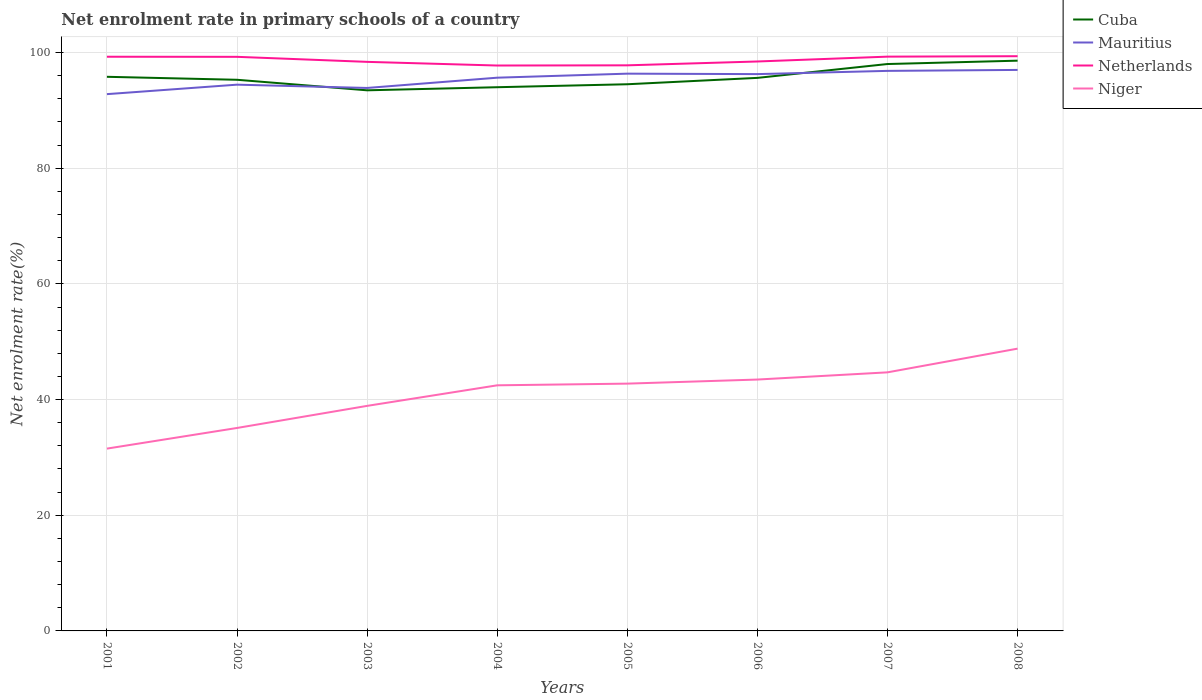How many different coloured lines are there?
Offer a terse response. 4. Does the line corresponding to Mauritius intersect with the line corresponding to Netherlands?
Offer a terse response. No. Across all years, what is the maximum net enrolment rate in primary schools in Niger?
Keep it short and to the point. 31.52. In which year was the net enrolment rate in primary schools in Netherlands maximum?
Offer a terse response. 2004. What is the total net enrolment rate in primary schools in Cuba in the graph?
Keep it short and to the point. -0.33. What is the difference between the highest and the second highest net enrolment rate in primary schools in Netherlands?
Your answer should be very brief. 1.61. What is the difference between the highest and the lowest net enrolment rate in primary schools in Niger?
Provide a succinct answer. 5. How many lines are there?
Ensure brevity in your answer.  4. How many years are there in the graph?
Provide a short and direct response. 8. What is the difference between two consecutive major ticks on the Y-axis?
Provide a short and direct response. 20. Are the values on the major ticks of Y-axis written in scientific E-notation?
Provide a short and direct response. No. How many legend labels are there?
Keep it short and to the point. 4. How are the legend labels stacked?
Offer a terse response. Vertical. What is the title of the graph?
Your response must be concise. Net enrolment rate in primary schools of a country. Does "Kuwait" appear as one of the legend labels in the graph?
Provide a succinct answer. No. What is the label or title of the Y-axis?
Give a very brief answer. Net enrolment rate(%). What is the Net enrolment rate(%) in Cuba in 2001?
Offer a terse response. 95.81. What is the Net enrolment rate(%) of Mauritius in 2001?
Offer a very short reply. 92.81. What is the Net enrolment rate(%) in Netherlands in 2001?
Your answer should be compact. 99.28. What is the Net enrolment rate(%) in Niger in 2001?
Keep it short and to the point. 31.52. What is the Net enrolment rate(%) in Cuba in 2002?
Make the answer very short. 95.29. What is the Net enrolment rate(%) of Mauritius in 2002?
Provide a short and direct response. 94.45. What is the Net enrolment rate(%) in Netherlands in 2002?
Offer a terse response. 99.26. What is the Net enrolment rate(%) of Niger in 2002?
Provide a short and direct response. 35.09. What is the Net enrolment rate(%) of Cuba in 2003?
Offer a terse response. 93.47. What is the Net enrolment rate(%) in Mauritius in 2003?
Your answer should be compact. 93.88. What is the Net enrolment rate(%) in Netherlands in 2003?
Your answer should be very brief. 98.39. What is the Net enrolment rate(%) of Niger in 2003?
Your answer should be compact. 38.91. What is the Net enrolment rate(%) of Cuba in 2004?
Your response must be concise. 94.01. What is the Net enrolment rate(%) of Mauritius in 2004?
Offer a very short reply. 95.65. What is the Net enrolment rate(%) of Netherlands in 2004?
Your answer should be compact. 97.76. What is the Net enrolment rate(%) in Niger in 2004?
Provide a succinct answer. 42.46. What is the Net enrolment rate(%) in Cuba in 2005?
Provide a succinct answer. 94.52. What is the Net enrolment rate(%) in Mauritius in 2005?
Provide a succinct answer. 96.35. What is the Net enrolment rate(%) in Netherlands in 2005?
Your response must be concise. 97.79. What is the Net enrolment rate(%) of Niger in 2005?
Make the answer very short. 42.76. What is the Net enrolment rate(%) in Cuba in 2006?
Give a very brief answer. 95.62. What is the Net enrolment rate(%) of Mauritius in 2006?
Offer a very short reply. 96.27. What is the Net enrolment rate(%) of Netherlands in 2006?
Make the answer very short. 98.46. What is the Net enrolment rate(%) of Niger in 2006?
Keep it short and to the point. 43.46. What is the Net enrolment rate(%) of Cuba in 2007?
Your answer should be compact. 98.02. What is the Net enrolment rate(%) of Mauritius in 2007?
Your answer should be very brief. 96.83. What is the Net enrolment rate(%) of Netherlands in 2007?
Offer a very short reply. 99.29. What is the Net enrolment rate(%) in Niger in 2007?
Give a very brief answer. 44.71. What is the Net enrolment rate(%) in Cuba in 2008?
Offer a very short reply. 98.6. What is the Net enrolment rate(%) of Mauritius in 2008?
Make the answer very short. 97. What is the Net enrolment rate(%) of Netherlands in 2008?
Provide a succinct answer. 99.37. What is the Net enrolment rate(%) in Niger in 2008?
Offer a very short reply. 48.81. Across all years, what is the maximum Net enrolment rate(%) in Cuba?
Make the answer very short. 98.6. Across all years, what is the maximum Net enrolment rate(%) in Mauritius?
Your answer should be compact. 97. Across all years, what is the maximum Net enrolment rate(%) in Netherlands?
Ensure brevity in your answer.  99.37. Across all years, what is the maximum Net enrolment rate(%) in Niger?
Provide a short and direct response. 48.81. Across all years, what is the minimum Net enrolment rate(%) in Cuba?
Provide a succinct answer. 93.47. Across all years, what is the minimum Net enrolment rate(%) in Mauritius?
Keep it short and to the point. 92.81. Across all years, what is the minimum Net enrolment rate(%) in Netherlands?
Provide a succinct answer. 97.76. Across all years, what is the minimum Net enrolment rate(%) in Niger?
Offer a very short reply. 31.52. What is the total Net enrolment rate(%) in Cuba in the graph?
Ensure brevity in your answer.  765.33. What is the total Net enrolment rate(%) of Mauritius in the graph?
Ensure brevity in your answer.  763.24. What is the total Net enrolment rate(%) in Netherlands in the graph?
Provide a succinct answer. 789.59. What is the total Net enrolment rate(%) of Niger in the graph?
Offer a terse response. 327.72. What is the difference between the Net enrolment rate(%) of Cuba in 2001 and that in 2002?
Offer a terse response. 0.52. What is the difference between the Net enrolment rate(%) of Mauritius in 2001 and that in 2002?
Offer a terse response. -1.64. What is the difference between the Net enrolment rate(%) of Netherlands in 2001 and that in 2002?
Make the answer very short. 0.01. What is the difference between the Net enrolment rate(%) in Niger in 2001 and that in 2002?
Offer a terse response. -3.57. What is the difference between the Net enrolment rate(%) in Cuba in 2001 and that in 2003?
Provide a short and direct response. 2.34. What is the difference between the Net enrolment rate(%) of Mauritius in 2001 and that in 2003?
Make the answer very short. -1.07. What is the difference between the Net enrolment rate(%) in Netherlands in 2001 and that in 2003?
Make the answer very short. 0.88. What is the difference between the Net enrolment rate(%) of Niger in 2001 and that in 2003?
Your answer should be very brief. -7.39. What is the difference between the Net enrolment rate(%) of Cuba in 2001 and that in 2004?
Your response must be concise. 1.8. What is the difference between the Net enrolment rate(%) of Mauritius in 2001 and that in 2004?
Offer a terse response. -2.85. What is the difference between the Net enrolment rate(%) in Netherlands in 2001 and that in 2004?
Your answer should be very brief. 1.52. What is the difference between the Net enrolment rate(%) of Niger in 2001 and that in 2004?
Provide a succinct answer. -10.94. What is the difference between the Net enrolment rate(%) in Cuba in 2001 and that in 2005?
Your response must be concise. 1.29. What is the difference between the Net enrolment rate(%) in Mauritius in 2001 and that in 2005?
Provide a short and direct response. -3.54. What is the difference between the Net enrolment rate(%) in Netherlands in 2001 and that in 2005?
Your response must be concise. 1.49. What is the difference between the Net enrolment rate(%) of Niger in 2001 and that in 2005?
Your answer should be compact. -11.23. What is the difference between the Net enrolment rate(%) in Cuba in 2001 and that in 2006?
Make the answer very short. 0.19. What is the difference between the Net enrolment rate(%) in Mauritius in 2001 and that in 2006?
Your answer should be compact. -3.46. What is the difference between the Net enrolment rate(%) in Netherlands in 2001 and that in 2006?
Make the answer very short. 0.82. What is the difference between the Net enrolment rate(%) of Niger in 2001 and that in 2006?
Keep it short and to the point. -11.94. What is the difference between the Net enrolment rate(%) in Cuba in 2001 and that in 2007?
Offer a terse response. -2.21. What is the difference between the Net enrolment rate(%) in Mauritius in 2001 and that in 2007?
Keep it short and to the point. -4.02. What is the difference between the Net enrolment rate(%) of Netherlands in 2001 and that in 2007?
Keep it short and to the point. -0.02. What is the difference between the Net enrolment rate(%) in Niger in 2001 and that in 2007?
Your answer should be compact. -13.19. What is the difference between the Net enrolment rate(%) in Cuba in 2001 and that in 2008?
Your answer should be compact. -2.79. What is the difference between the Net enrolment rate(%) of Mauritius in 2001 and that in 2008?
Make the answer very short. -4.19. What is the difference between the Net enrolment rate(%) in Netherlands in 2001 and that in 2008?
Ensure brevity in your answer.  -0.09. What is the difference between the Net enrolment rate(%) in Niger in 2001 and that in 2008?
Give a very brief answer. -17.29. What is the difference between the Net enrolment rate(%) in Cuba in 2002 and that in 2003?
Your response must be concise. 1.82. What is the difference between the Net enrolment rate(%) of Mauritius in 2002 and that in 2003?
Provide a short and direct response. 0.57. What is the difference between the Net enrolment rate(%) in Netherlands in 2002 and that in 2003?
Keep it short and to the point. 0.87. What is the difference between the Net enrolment rate(%) in Niger in 2002 and that in 2003?
Your answer should be very brief. -3.82. What is the difference between the Net enrolment rate(%) in Cuba in 2002 and that in 2004?
Your answer should be compact. 1.29. What is the difference between the Net enrolment rate(%) in Mauritius in 2002 and that in 2004?
Your response must be concise. -1.21. What is the difference between the Net enrolment rate(%) of Netherlands in 2002 and that in 2004?
Keep it short and to the point. 1.5. What is the difference between the Net enrolment rate(%) in Niger in 2002 and that in 2004?
Offer a terse response. -7.37. What is the difference between the Net enrolment rate(%) of Cuba in 2002 and that in 2005?
Give a very brief answer. 0.77. What is the difference between the Net enrolment rate(%) in Mauritius in 2002 and that in 2005?
Make the answer very short. -1.9. What is the difference between the Net enrolment rate(%) in Netherlands in 2002 and that in 2005?
Give a very brief answer. 1.47. What is the difference between the Net enrolment rate(%) in Niger in 2002 and that in 2005?
Keep it short and to the point. -7.67. What is the difference between the Net enrolment rate(%) of Cuba in 2002 and that in 2006?
Your answer should be very brief. -0.33. What is the difference between the Net enrolment rate(%) of Mauritius in 2002 and that in 2006?
Keep it short and to the point. -1.82. What is the difference between the Net enrolment rate(%) in Netherlands in 2002 and that in 2006?
Provide a succinct answer. 0.81. What is the difference between the Net enrolment rate(%) of Niger in 2002 and that in 2006?
Provide a succinct answer. -8.37. What is the difference between the Net enrolment rate(%) of Cuba in 2002 and that in 2007?
Provide a short and direct response. -2.72. What is the difference between the Net enrolment rate(%) in Mauritius in 2002 and that in 2007?
Make the answer very short. -2.39. What is the difference between the Net enrolment rate(%) in Netherlands in 2002 and that in 2007?
Give a very brief answer. -0.03. What is the difference between the Net enrolment rate(%) in Niger in 2002 and that in 2007?
Your answer should be very brief. -9.62. What is the difference between the Net enrolment rate(%) in Cuba in 2002 and that in 2008?
Your response must be concise. -3.3. What is the difference between the Net enrolment rate(%) of Mauritius in 2002 and that in 2008?
Give a very brief answer. -2.55. What is the difference between the Net enrolment rate(%) in Netherlands in 2002 and that in 2008?
Ensure brevity in your answer.  -0.11. What is the difference between the Net enrolment rate(%) of Niger in 2002 and that in 2008?
Offer a terse response. -13.72. What is the difference between the Net enrolment rate(%) of Cuba in 2003 and that in 2004?
Provide a short and direct response. -0.53. What is the difference between the Net enrolment rate(%) in Mauritius in 2003 and that in 2004?
Make the answer very short. -1.78. What is the difference between the Net enrolment rate(%) in Netherlands in 2003 and that in 2004?
Your response must be concise. 0.63. What is the difference between the Net enrolment rate(%) of Niger in 2003 and that in 2004?
Your response must be concise. -3.55. What is the difference between the Net enrolment rate(%) of Cuba in 2003 and that in 2005?
Provide a succinct answer. -1.05. What is the difference between the Net enrolment rate(%) of Mauritius in 2003 and that in 2005?
Make the answer very short. -2.47. What is the difference between the Net enrolment rate(%) of Netherlands in 2003 and that in 2005?
Keep it short and to the point. 0.6. What is the difference between the Net enrolment rate(%) of Niger in 2003 and that in 2005?
Provide a succinct answer. -3.85. What is the difference between the Net enrolment rate(%) of Cuba in 2003 and that in 2006?
Keep it short and to the point. -2.15. What is the difference between the Net enrolment rate(%) of Mauritius in 2003 and that in 2006?
Provide a succinct answer. -2.39. What is the difference between the Net enrolment rate(%) in Netherlands in 2003 and that in 2006?
Offer a very short reply. -0.06. What is the difference between the Net enrolment rate(%) in Niger in 2003 and that in 2006?
Give a very brief answer. -4.55. What is the difference between the Net enrolment rate(%) in Cuba in 2003 and that in 2007?
Your response must be concise. -4.55. What is the difference between the Net enrolment rate(%) in Mauritius in 2003 and that in 2007?
Your answer should be very brief. -2.95. What is the difference between the Net enrolment rate(%) in Netherlands in 2003 and that in 2007?
Offer a terse response. -0.9. What is the difference between the Net enrolment rate(%) of Niger in 2003 and that in 2007?
Keep it short and to the point. -5.8. What is the difference between the Net enrolment rate(%) in Cuba in 2003 and that in 2008?
Your answer should be compact. -5.12. What is the difference between the Net enrolment rate(%) of Mauritius in 2003 and that in 2008?
Ensure brevity in your answer.  -3.12. What is the difference between the Net enrolment rate(%) of Netherlands in 2003 and that in 2008?
Your response must be concise. -0.98. What is the difference between the Net enrolment rate(%) of Niger in 2003 and that in 2008?
Offer a terse response. -9.9. What is the difference between the Net enrolment rate(%) of Cuba in 2004 and that in 2005?
Your answer should be compact. -0.51. What is the difference between the Net enrolment rate(%) of Mauritius in 2004 and that in 2005?
Keep it short and to the point. -0.7. What is the difference between the Net enrolment rate(%) of Netherlands in 2004 and that in 2005?
Give a very brief answer. -0.03. What is the difference between the Net enrolment rate(%) in Niger in 2004 and that in 2005?
Provide a short and direct response. -0.29. What is the difference between the Net enrolment rate(%) of Cuba in 2004 and that in 2006?
Offer a very short reply. -1.62. What is the difference between the Net enrolment rate(%) in Mauritius in 2004 and that in 2006?
Provide a succinct answer. -0.62. What is the difference between the Net enrolment rate(%) in Netherlands in 2004 and that in 2006?
Keep it short and to the point. -0.7. What is the difference between the Net enrolment rate(%) of Niger in 2004 and that in 2006?
Make the answer very short. -1. What is the difference between the Net enrolment rate(%) in Cuba in 2004 and that in 2007?
Give a very brief answer. -4.01. What is the difference between the Net enrolment rate(%) in Mauritius in 2004 and that in 2007?
Your answer should be very brief. -1.18. What is the difference between the Net enrolment rate(%) of Netherlands in 2004 and that in 2007?
Offer a very short reply. -1.53. What is the difference between the Net enrolment rate(%) in Niger in 2004 and that in 2007?
Provide a succinct answer. -2.24. What is the difference between the Net enrolment rate(%) of Cuba in 2004 and that in 2008?
Your response must be concise. -4.59. What is the difference between the Net enrolment rate(%) in Mauritius in 2004 and that in 2008?
Keep it short and to the point. -1.34. What is the difference between the Net enrolment rate(%) in Netherlands in 2004 and that in 2008?
Keep it short and to the point. -1.61. What is the difference between the Net enrolment rate(%) in Niger in 2004 and that in 2008?
Provide a succinct answer. -6.34. What is the difference between the Net enrolment rate(%) in Cuba in 2005 and that in 2006?
Your answer should be very brief. -1.1. What is the difference between the Net enrolment rate(%) in Mauritius in 2005 and that in 2006?
Make the answer very short. 0.08. What is the difference between the Net enrolment rate(%) of Netherlands in 2005 and that in 2006?
Offer a terse response. -0.67. What is the difference between the Net enrolment rate(%) of Niger in 2005 and that in 2006?
Keep it short and to the point. -0.7. What is the difference between the Net enrolment rate(%) in Cuba in 2005 and that in 2007?
Your response must be concise. -3.5. What is the difference between the Net enrolment rate(%) of Mauritius in 2005 and that in 2007?
Your answer should be compact. -0.48. What is the difference between the Net enrolment rate(%) in Netherlands in 2005 and that in 2007?
Provide a short and direct response. -1.5. What is the difference between the Net enrolment rate(%) of Niger in 2005 and that in 2007?
Your answer should be very brief. -1.95. What is the difference between the Net enrolment rate(%) of Cuba in 2005 and that in 2008?
Your response must be concise. -4.08. What is the difference between the Net enrolment rate(%) of Mauritius in 2005 and that in 2008?
Offer a terse response. -0.65. What is the difference between the Net enrolment rate(%) in Netherlands in 2005 and that in 2008?
Keep it short and to the point. -1.58. What is the difference between the Net enrolment rate(%) in Niger in 2005 and that in 2008?
Your answer should be compact. -6.05. What is the difference between the Net enrolment rate(%) of Cuba in 2006 and that in 2007?
Your answer should be compact. -2.4. What is the difference between the Net enrolment rate(%) of Mauritius in 2006 and that in 2007?
Offer a very short reply. -0.56. What is the difference between the Net enrolment rate(%) in Netherlands in 2006 and that in 2007?
Keep it short and to the point. -0.84. What is the difference between the Net enrolment rate(%) of Niger in 2006 and that in 2007?
Keep it short and to the point. -1.25. What is the difference between the Net enrolment rate(%) in Cuba in 2006 and that in 2008?
Provide a succinct answer. -2.97. What is the difference between the Net enrolment rate(%) in Mauritius in 2006 and that in 2008?
Your response must be concise. -0.73. What is the difference between the Net enrolment rate(%) in Netherlands in 2006 and that in 2008?
Offer a very short reply. -0.91. What is the difference between the Net enrolment rate(%) in Niger in 2006 and that in 2008?
Your answer should be very brief. -5.35. What is the difference between the Net enrolment rate(%) in Cuba in 2007 and that in 2008?
Offer a terse response. -0.58. What is the difference between the Net enrolment rate(%) of Mauritius in 2007 and that in 2008?
Provide a succinct answer. -0.16. What is the difference between the Net enrolment rate(%) of Netherlands in 2007 and that in 2008?
Your answer should be compact. -0.08. What is the difference between the Net enrolment rate(%) in Niger in 2007 and that in 2008?
Give a very brief answer. -4.1. What is the difference between the Net enrolment rate(%) in Cuba in 2001 and the Net enrolment rate(%) in Mauritius in 2002?
Provide a short and direct response. 1.36. What is the difference between the Net enrolment rate(%) of Cuba in 2001 and the Net enrolment rate(%) of Netherlands in 2002?
Make the answer very short. -3.45. What is the difference between the Net enrolment rate(%) of Cuba in 2001 and the Net enrolment rate(%) of Niger in 2002?
Your response must be concise. 60.72. What is the difference between the Net enrolment rate(%) in Mauritius in 2001 and the Net enrolment rate(%) in Netherlands in 2002?
Provide a short and direct response. -6.45. What is the difference between the Net enrolment rate(%) of Mauritius in 2001 and the Net enrolment rate(%) of Niger in 2002?
Provide a short and direct response. 57.72. What is the difference between the Net enrolment rate(%) in Netherlands in 2001 and the Net enrolment rate(%) in Niger in 2002?
Make the answer very short. 64.19. What is the difference between the Net enrolment rate(%) in Cuba in 2001 and the Net enrolment rate(%) in Mauritius in 2003?
Ensure brevity in your answer.  1.93. What is the difference between the Net enrolment rate(%) in Cuba in 2001 and the Net enrolment rate(%) in Netherlands in 2003?
Make the answer very short. -2.58. What is the difference between the Net enrolment rate(%) in Cuba in 2001 and the Net enrolment rate(%) in Niger in 2003?
Your response must be concise. 56.9. What is the difference between the Net enrolment rate(%) in Mauritius in 2001 and the Net enrolment rate(%) in Netherlands in 2003?
Offer a terse response. -5.58. What is the difference between the Net enrolment rate(%) of Mauritius in 2001 and the Net enrolment rate(%) of Niger in 2003?
Provide a succinct answer. 53.9. What is the difference between the Net enrolment rate(%) of Netherlands in 2001 and the Net enrolment rate(%) of Niger in 2003?
Give a very brief answer. 60.37. What is the difference between the Net enrolment rate(%) in Cuba in 2001 and the Net enrolment rate(%) in Mauritius in 2004?
Offer a terse response. 0.15. What is the difference between the Net enrolment rate(%) in Cuba in 2001 and the Net enrolment rate(%) in Netherlands in 2004?
Keep it short and to the point. -1.95. What is the difference between the Net enrolment rate(%) of Cuba in 2001 and the Net enrolment rate(%) of Niger in 2004?
Provide a succinct answer. 53.34. What is the difference between the Net enrolment rate(%) in Mauritius in 2001 and the Net enrolment rate(%) in Netherlands in 2004?
Offer a very short reply. -4.95. What is the difference between the Net enrolment rate(%) of Mauritius in 2001 and the Net enrolment rate(%) of Niger in 2004?
Provide a short and direct response. 50.34. What is the difference between the Net enrolment rate(%) in Netherlands in 2001 and the Net enrolment rate(%) in Niger in 2004?
Make the answer very short. 56.81. What is the difference between the Net enrolment rate(%) in Cuba in 2001 and the Net enrolment rate(%) in Mauritius in 2005?
Ensure brevity in your answer.  -0.54. What is the difference between the Net enrolment rate(%) of Cuba in 2001 and the Net enrolment rate(%) of Netherlands in 2005?
Make the answer very short. -1.98. What is the difference between the Net enrolment rate(%) of Cuba in 2001 and the Net enrolment rate(%) of Niger in 2005?
Ensure brevity in your answer.  53.05. What is the difference between the Net enrolment rate(%) of Mauritius in 2001 and the Net enrolment rate(%) of Netherlands in 2005?
Your response must be concise. -4.98. What is the difference between the Net enrolment rate(%) in Mauritius in 2001 and the Net enrolment rate(%) in Niger in 2005?
Provide a short and direct response. 50.05. What is the difference between the Net enrolment rate(%) of Netherlands in 2001 and the Net enrolment rate(%) of Niger in 2005?
Make the answer very short. 56.52. What is the difference between the Net enrolment rate(%) of Cuba in 2001 and the Net enrolment rate(%) of Mauritius in 2006?
Your answer should be compact. -0.46. What is the difference between the Net enrolment rate(%) of Cuba in 2001 and the Net enrolment rate(%) of Netherlands in 2006?
Offer a very short reply. -2.65. What is the difference between the Net enrolment rate(%) of Cuba in 2001 and the Net enrolment rate(%) of Niger in 2006?
Keep it short and to the point. 52.35. What is the difference between the Net enrolment rate(%) in Mauritius in 2001 and the Net enrolment rate(%) in Netherlands in 2006?
Provide a succinct answer. -5.65. What is the difference between the Net enrolment rate(%) of Mauritius in 2001 and the Net enrolment rate(%) of Niger in 2006?
Provide a succinct answer. 49.35. What is the difference between the Net enrolment rate(%) in Netherlands in 2001 and the Net enrolment rate(%) in Niger in 2006?
Keep it short and to the point. 55.81. What is the difference between the Net enrolment rate(%) in Cuba in 2001 and the Net enrolment rate(%) in Mauritius in 2007?
Provide a short and direct response. -1.02. What is the difference between the Net enrolment rate(%) of Cuba in 2001 and the Net enrolment rate(%) of Netherlands in 2007?
Your response must be concise. -3.48. What is the difference between the Net enrolment rate(%) of Cuba in 2001 and the Net enrolment rate(%) of Niger in 2007?
Provide a short and direct response. 51.1. What is the difference between the Net enrolment rate(%) of Mauritius in 2001 and the Net enrolment rate(%) of Netherlands in 2007?
Your answer should be compact. -6.48. What is the difference between the Net enrolment rate(%) in Mauritius in 2001 and the Net enrolment rate(%) in Niger in 2007?
Provide a succinct answer. 48.1. What is the difference between the Net enrolment rate(%) of Netherlands in 2001 and the Net enrolment rate(%) of Niger in 2007?
Your response must be concise. 54.57. What is the difference between the Net enrolment rate(%) in Cuba in 2001 and the Net enrolment rate(%) in Mauritius in 2008?
Provide a succinct answer. -1.19. What is the difference between the Net enrolment rate(%) of Cuba in 2001 and the Net enrolment rate(%) of Netherlands in 2008?
Provide a succinct answer. -3.56. What is the difference between the Net enrolment rate(%) in Cuba in 2001 and the Net enrolment rate(%) in Niger in 2008?
Give a very brief answer. 47. What is the difference between the Net enrolment rate(%) of Mauritius in 2001 and the Net enrolment rate(%) of Netherlands in 2008?
Your answer should be very brief. -6.56. What is the difference between the Net enrolment rate(%) in Mauritius in 2001 and the Net enrolment rate(%) in Niger in 2008?
Your answer should be compact. 44. What is the difference between the Net enrolment rate(%) in Netherlands in 2001 and the Net enrolment rate(%) in Niger in 2008?
Your response must be concise. 50.47. What is the difference between the Net enrolment rate(%) in Cuba in 2002 and the Net enrolment rate(%) in Mauritius in 2003?
Your answer should be compact. 1.41. What is the difference between the Net enrolment rate(%) in Cuba in 2002 and the Net enrolment rate(%) in Netherlands in 2003?
Offer a very short reply. -3.1. What is the difference between the Net enrolment rate(%) in Cuba in 2002 and the Net enrolment rate(%) in Niger in 2003?
Your response must be concise. 56.38. What is the difference between the Net enrolment rate(%) of Mauritius in 2002 and the Net enrolment rate(%) of Netherlands in 2003?
Offer a terse response. -3.94. What is the difference between the Net enrolment rate(%) of Mauritius in 2002 and the Net enrolment rate(%) of Niger in 2003?
Give a very brief answer. 55.54. What is the difference between the Net enrolment rate(%) in Netherlands in 2002 and the Net enrolment rate(%) in Niger in 2003?
Your answer should be very brief. 60.35. What is the difference between the Net enrolment rate(%) of Cuba in 2002 and the Net enrolment rate(%) of Mauritius in 2004?
Provide a succinct answer. -0.36. What is the difference between the Net enrolment rate(%) of Cuba in 2002 and the Net enrolment rate(%) of Netherlands in 2004?
Offer a very short reply. -2.46. What is the difference between the Net enrolment rate(%) of Cuba in 2002 and the Net enrolment rate(%) of Niger in 2004?
Provide a short and direct response. 52.83. What is the difference between the Net enrolment rate(%) in Mauritius in 2002 and the Net enrolment rate(%) in Netherlands in 2004?
Provide a short and direct response. -3.31. What is the difference between the Net enrolment rate(%) of Mauritius in 2002 and the Net enrolment rate(%) of Niger in 2004?
Provide a succinct answer. 51.98. What is the difference between the Net enrolment rate(%) of Netherlands in 2002 and the Net enrolment rate(%) of Niger in 2004?
Your response must be concise. 56.8. What is the difference between the Net enrolment rate(%) in Cuba in 2002 and the Net enrolment rate(%) in Mauritius in 2005?
Ensure brevity in your answer.  -1.06. What is the difference between the Net enrolment rate(%) of Cuba in 2002 and the Net enrolment rate(%) of Netherlands in 2005?
Provide a short and direct response. -2.5. What is the difference between the Net enrolment rate(%) in Cuba in 2002 and the Net enrolment rate(%) in Niger in 2005?
Ensure brevity in your answer.  52.54. What is the difference between the Net enrolment rate(%) of Mauritius in 2002 and the Net enrolment rate(%) of Netherlands in 2005?
Your answer should be compact. -3.34. What is the difference between the Net enrolment rate(%) of Mauritius in 2002 and the Net enrolment rate(%) of Niger in 2005?
Ensure brevity in your answer.  51.69. What is the difference between the Net enrolment rate(%) of Netherlands in 2002 and the Net enrolment rate(%) of Niger in 2005?
Provide a short and direct response. 56.5. What is the difference between the Net enrolment rate(%) of Cuba in 2002 and the Net enrolment rate(%) of Mauritius in 2006?
Provide a succinct answer. -0.98. What is the difference between the Net enrolment rate(%) of Cuba in 2002 and the Net enrolment rate(%) of Netherlands in 2006?
Give a very brief answer. -3.16. What is the difference between the Net enrolment rate(%) of Cuba in 2002 and the Net enrolment rate(%) of Niger in 2006?
Offer a very short reply. 51.83. What is the difference between the Net enrolment rate(%) of Mauritius in 2002 and the Net enrolment rate(%) of Netherlands in 2006?
Keep it short and to the point. -4.01. What is the difference between the Net enrolment rate(%) in Mauritius in 2002 and the Net enrolment rate(%) in Niger in 2006?
Provide a short and direct response. 50.99. What is the difference between the Net enrolment rate(%) in Netherlands in 2002 and the Net enrolment rate(%) in Niger in 2006?
Give a very brief answer. 55.8. What is the difference between the Net enrolment rate(%) in Cuba in 2002 and the Net enrolment rate(%) in Mauritius in 2007?
Your response must be concise. -1.54. What is the difference between the Net enrolment rate(%) of Cuba in 2002 and the Net enrolment rate(%) of Netherlands in 2007?
Offer a terse response. -4. What is the difference between the Net enrolment rate(%) of Cuba in 2002 and the Net enrolment rate(%) of Niger in 2007?
Your response must be concise. 50.58. What is the difference between the Net enrolment rate(%) in Mauritius in 2002 and the Net enrolment rate(%) in Netherlands in 2007?
Offer a terse response. -4.84. What is the difference between the Net enrolment rate(%) of Mauritius in 2002 and the Net enrolment rate(%) of Niger in 2007?
Offer a terse response. 49.74. What is the difference between the Net enrolment rate(%) in Netherlands in 2002 and the Net enrolment rate(%) in Niger in 2007?
Keep it short and to the point. 54.55. What is the difference between the Net enrolment rate(%) of Cuba in 2002 and the Net enrolment rate(%) of Mauritius in 2008?
Offer a very short reply. -1.7. What is the difference between the Net enrolment rate(%) in Cuba in 2002 and the Net enrolment rate(%) in Netherlands in 2008?
Offer a terse response. -4.08. What is the difference between the Net enrolment rate(%) of Cuba in 2002 and the Net enrolment rate(%) of Niger in 2008?
Offer a very short reply. 46.49. What is the difference between the Net enrolment rate(%) of Mauritius in 2002 and the Net enrolment rate(%) of Netherlands in 2008?
Give a very brief answer. -4.92. What is the difference between the Net enrolment rate(%) in Mauritius in 2002 and the Net enrolment rate(%) in Niger in 2008?
Give a very brief answer. 45.64. What is the difference between the Net enrolment rate(%) of Netherlands in 2002 and the Net enrolment rate(%) of Niger in 2008?
Offer a terse response. 50.45. What is the difference between the Net enrolment rate(%) of Cuba in 2003 and the Net enrolment rate(%) of Mauritius in 2004?
Offer a very short reply. -2.18. What is the difference between the Net enrolment rate(%) in Cuba in 2003 and the Net enrolment rate(%) in Netherlands in 2004?
Provide a succinct answer. -4.29. What is the difference between the Net enrolment rate(%) of Cuba in 2003 and the Net enrolment rate(%) of Niger in 2004?
Your answer should be very brief. 51.01. What is the difference between the Net enrolment rate(%) in Mauritius in 2003 and the Net enrolment rate(%) in Netherlands in 2004?
Your answer should be very brief. -3.88. What is the difference between the Net enrolment rate(%) in Mauritius in 2003 and the Net enrolment rate(%) in Niger in 2004?
Provide a short and direct response. 51.41. What is the difference between the Net enrolment rate(%) in Netherlands in 2003 and the Net enrolment rate(%) in Niger in 2004?
Offer a terse response. 55.93. What is the difference between the Net enrolment rate(%) in Cuba in 2003 and the Net enrolment rate(%) in Mauritius in 2005?
Your answer should be compact. -2.88. What is the difference between the Net enrolment rate(%) of Cuba in 2003 and the Net enrolment rate(%) of Netherlands in 2005?
Your answer should be compact. -4.32. What is the difference between the Net enrolment rate(%) in Cuba in 2003 and the Net enrolment rate(%) in Niger in 2005?
Offer a terse response. 50.71. What is the difference between the Net enrolment rate(%) of Mauritius in 2003 and the Net enrolment rate(%) of Netherlands in 2005?
Offer a terse response. -3.91. What is the difference between the Net enrolment rate(%) of Mauritius in 2003 and the Net enrolment rate(%) of Niger in 2005?
Provide a succinct answer. 51.12. What is the difference between the Net enrolment rate(%) of Netherlands in 2003 and the Net enrolment rate(%) of Niger in 2005?
Offer a terse response. 55.63. What is the difference between the Net enrolment rate(%) of Cuba in 2003 and the Net enrolment rate(%) of Mauritius in 2006?
Your answer should be very brief. -2.8. What is the difference between the Net enrolment rate(%) in Cuba in 2003 and the Net enrolment rate(%) in Netherlands in 2006?
Offer a terse response. -4.98. What is the difference between the Net enrolment rate(%) of Cuba in 2003 and the Net enrolment rate(%) of Niger in 2006?
Give a very brief answer. 50.01. What is the difference between the Net enrolment rate(%) of Mauritius in 2003 and the Net enrolment rate(%) of Netherlands in 2006?
Keep it short and to the point. -4.58. What is the difference between the Net enrolment rate(%) of Mauritius in 2003 and the Net enrolment rate(%) of Niger in 2006?
Offer a very short reply. 50.42. What is the difference between the Net enrolment rate(%) in Netherlands in 2003 and the Net enrolment rate(%) in Niger in 2006?
Keep it short and to the point. 54.93. What is the difference between the Net enrolment rate(%) of Cuba in 2003 and the Net enrolment rate(%) of Mauritius in 2007?
Your answer should be compact. -3.36. What is the difference between the Net enrolment rate(%) of Cuba in 2003 and the Net enrolment rate(%) of Netherlands in 2007?
Your response must be concise. -5.82. What is the difference between the Net enrolment rate(%) of Cuba in 2003 and the Net enrolment rate(%) of Niger in 2007?
Your answer should be compact. 48.76. What is the difference between the Net enrolment rate(%) in Mauritius in 2003 and the Net enrolment rate(%) in Netherlands in 2007?
Offer a terse response. -5.41. What is the difference between the Net enrolment rate(%) in Mauritius in 2003 and the Net enrolment rate(%) in Niger in 2007?
Ensure brevity in your answer.  49.17. What is the difference between the Net enrolment rate(%) in Netherlands in 2003 and the Net enrolment rate(%) in Niger in 2007?
Provide a short and direct response. 53.68. What is the difference between the Net enrolment rate(%) in Cuba in 2003 and the Net enrolment rate(%) in Mauritius in 2008?
Offer a very short reply. -3.53. What is the difference between the Net enrolment rate(%) in Cuba in 2003 and the Net enrolment rate(%) in Netherlands in 2008?
Offer a terse response. -5.9. What is the difference between the Net enrolment rate(%) in Cuba in 2003 and the Net enrolment rate(%) in Niger in 2008?
Keep it short and to the point. 44.66. What is the difference between the Net enrolment rate(%) in Mauritius in 2003 and the Net enrolment rate(%) in Netherlands in 2008?
Your answer should be very brief. -5.49. What is the difference between the Net enrolment rate(%) in Mauritius in 2003 and the Net enrolment rate(%) in Niger in 2008?
Give a very brief answer. 45.07. What is the difference between the Net enrolment rate(%) in Netherlands in 2003 and the Net enrolment rate(%) in Niger in 2008?
Your response must be concise. 49.58. What is the difference between the Net enrolment rate(%) of Cuba in 2004 and the Net enrolment rate(%) of Mauritius in 2005?
Offer a terse response. -2.35. What is the difference between the Net enrolment rate(%) in Cuba in 2004 and the Net enrolment rate(%) in Netherlands in 2005?
Offer a very short reply. -3.78. What is the difference between the Net enrolment rate(%) of Cuba in 2004 and the Net enrolment rate(%) of Niger in 2005?
Your answer should be very brief. 51.25. What is the difference between the Net enrolment rate(%) in Mauritius in 2004 and the Net enrolment rate(%) in Netherlands in 2005?
Offer a very short reply. -2.14. What is the difference between the Net enrolment rate(%) in Mauritius in 2004 and the Net enrolment rate(%) in Niger in 2005?
Give a very brief answer. 52.9. What is the difference between the Net enrolment rate(%) of Netherlands in 2004 and the Net enrolment rate(%) of Niger in 2005?
Offer a terse response. 55. What is the difference between the Net enrolment rate(%) of Cuba in 2004 and the Net enrolment rate(%) of Mauritius in 2006?
Make the answer very short. -2.27. What is the difference between the Net enrolment rate(%) in Cuba in 2004 and the Net enrolment rate(%) in Netherlands in 2006?
Your answer should be compact. -4.45. What is the difference between the Net enrolment rate(%) of Cuba in 2004 and the Net enrolment rate(%) of Niger in 2006?
Your response must be concise. 50.54. What is the difference between the Net enrolment rate(%) of Mauritius in 2004 and the Net enrolment rate(%) of Netherlands in 2006?
Your answer should be compact. -2.8. What is the difference between the Net enrolment rate(%) of Mauritius in 2004 and the Net enrolment rate(%) of Niger in 2006?
Offer a terse response. 52.19. What is the difference between the Net enrolment rate(%) of Netherlands in 2004 and the Net enrolment rate(%) of Niger in 2006?
Offer a terse response. 54.3. What is the difference between the Net enrolment rate(%) of Cuba in 2004 and the Net enrolment rate(%) of Mauritius in 2007?
Provide a succinct answer. -2.83. What is the difference between the Net enrolment rate(%) in Cuba in 2004 and the Net enrolment rate(%) in Netherlands in 2007?
Give a very brief answer. -5.29. What is the difference between the Net enrolment rate(%) of Cuba in 2004 and the Net enrolment rate(%) of Niger in 2007?
Your answer should be very brief. 49.3. What is the difference between the Net enrolment rate(%) of Mauritius in 2004 and the Net enrolment rate(%) of Netherlands in 2007?
Provide a short and direct response. -3.64. What is the difference between the Net enrolment rate(%) of Mauritius in 2004 and the Net enrolment rate(%) of Niger in 2007?
Provide a short and direct response. 50.95. What is the difference between the Net enrolment rate(%) of Netherlands in 2004 and the Net enrolment rate(%) of Niger in 2007?
Keep it short and to the point. 53.05. What is the difference between the Net enrolment rate(%) of Cuba in 2004 and the Net enrolment rate(%) of Mauritius in 2008?
Your answer should be very brief. -2.99. What is the difference between the Net enrolment rate(%) of Cuba in 2004 and the Net enrolment rate(%) of Netherlands in 2008?
Your response must be concise. -5.36. What is the difference between the Net enrolment rate(%) in Cuba in 2004 and the Net enrolment rate(%) in Niger in 2008?
Give a very brief answer. 45.2. What is the difference between the Net enrolment rate(%) in Mauritius in 2004 and the Net enrolment rate(%) in Netherlands in 2008?
Provide a succinct answer. -3.72. What is the difference between the Net enrolment rate(%) of Mauritius in 2004 and the Net enrolment rate(%) of Niger in 2008?
Ensure brevity in your answer.  46.85. What is the difference between the Net enrolment rate(%) in Netherlands in 2004 and the Net enrolment rate(%) in Niger in 2008?
Offer a very short reply. 48.95. What is the difference between the Net enrolment rate(%) of Cuba in 2005 and the Net enrolment rate(%) of Mauritius in 2006?
Provide a succinct answer. -1.75. What is the difference between the Net enrolment rate(%) in Cuba in 2005 and the Net enrolment rate(%) in Netherlands in 2006?
Keep it short and to the point. -3.94. What is the difference between the Net enrolment rate(%) of Cuba in 2005 and the Net enrolment rate(%) of Niger in 2006?
Your response must be concise. 51.06. What is the difference between the Net enrolment rate(%) of Mauritius in 2005 and the Net enrolment rate(%) of Netherlands in 2006?
Offer a terse response. -2.1. What is the difference between the Net enrolment rate(%) in Mauritius in 2005 and the Net enrolment rate(%) in Niger in 2006?
Your answer should be very brief. 52.89. What is the difference between the Net enrolment rate(%) in Netherlands in 2005 and the Net enrolment rate(%) in Niger in 2006?
Your answer should be very brief. 54.33. What is the difference between the Net enrolment rate(%) of Cuba in 2005 and the Net enrolment rate(%) of Mauritius in 2007?
Offer a terse response. -2.31. What is the difference between the Net enrolment rate(%) of Cuba in 2005 and the Net enrolment rate(%) of Netherlands in 2007?
Give a very brief answer. -4.77. What is the difference between the Net enrolment rate(%) in Cuba in 2005 and the Net enrolment rate(%) in Niger in 2007?
Make the answer very short. 49.81. What is the difference between the Net enrolment rate(%) of Mauritius in 2005 and the Net enrolment rate(%) of Netherlands in 2007?
Your answer should be compact. -2.94. What is the difference between the Net enrolment rate(%) of Mauritius in 2005 and the Net enrolment rate(%) of Niger in 2007?
Your response must be concise. 51.64. What is the difference between the Net enrolment rate(%) of Netherlands in 2005 and the Net enrolment rate(%) of Niger in 2007?
Keep it short and to the point. 53.08. What is the difference between the Net enrolment rate(%) in Cuba in 2005 and the Net enrolment rate(%) in Mauritius in 2008?
Provide a short and direct response. -2.48. What is the difference between the Net enrolment rate(%) of Cuba in 2005 and the Net enrolment rate(%) of Netherlands in 2008?
Give a very brief answer. -4.85. What is the difference between the Net enrolment rate(%) in Cuba in 2005 and the Net enrolment rate(%) in Niger in 2008?
Your answer should be very brief. 45.71. What is the difference between the Net enrolment rate(%) in Mauritius in 2005 and the Net enrolment rate(%) in Netherlands in 2008?
Provide a short and direct response. -3.02. What is the difference between the Net enrolment rate(%) in Mauritius in 2005 and the Net enrolment rate(%) in Niger in 2008?
Provide a short and direct response. 47.54. What is the difference between the Net enrolment rate(%) of Netherlands in 2005 and the Net enrolment rate(%) of Niger in 2008?
Provide a short and direct response. 48.98. What is the difference between the Net enrolment rate(%) in Cuba in 2006 and the Net enrolment rate(%) in Mauritius in 2007?
Offer a terse response. -1.21. What is the difference between the Net enrolment rate(%) of Cuba in 2006 and the Net enrolment rate(%) of Netherlands in 2007?
Your answer should be very brief. -3.67. What is the difference between the Net enrolment rate(%) of Cuba in 2006 and the Net enrolment rate(%) of Niger in 2007?
Give a very brief answer. 50.91. What is the difference between the Net enrolment rate(%) of Mauritius in 2006 and the Net enrolment rate(%) of Netherlands in 2007?
Your response must be concise. -3.02. What is the difference between the Net enrolment rate(%) in Mauritius in 2006 and the Net enrolment rate(%) in Niger in 2007?
Give a very brief answer. 51.56. What is the difference between the Net enrolment rate(%) of Netherlands in 2006 and the Net enrolment rate(%) of Niger in 2007?
Offer a terse response. 53.75. What is the difference between the Net enrolment rate(%) in Cuba in 2006 and the Net enrolment rate(%) in Mauritius in 2008?
Keep it short and to the point. -1.38. What is the difference between the Net enrolment rate(%) of Cuba in 2006 and the Net enrolment rate(%) of Netherlands in 2008?
Your response must be concise. -3.75. What is the difference between the Net enrolment rate(%) of Cuba in 2006 and the Net enrolment rate(%) of Niger in 2008?
Offer a terse response. 46.81. What is the difference between the Net enrolment rate(%) in Mauritius in 2006 and the Net enrolment rate(%) in Netherlands in 2008?
Offer a terse response. -3.1. What is the difference between the Net enrolment rate(%) in Mauritius in 2006 and the Net enrolment rate(%) in Niger in 2008?
Ensure brevity in your answer.  47.46. What is the difference between the Net enrolment rate(%) of Netherlands in 2006 and the Net enrolment rate(%) of Niger in 2008?
Offer a terse response. 49.65. What is the difference between the Net enrolment rate(%) of Cuba in 2007 and the Net enrolment rate(%) of Mauritius in 2008?
Your answer should be compact. 1.02. What is the difference between the Net enrolment rate(%) of Cuba in 2007 and the Net enrolment rate(%) of Netherlands in 2008?
Your response must be concise. -1.35. What is the difference between the Net enrolment rate(%) of Cuba in 2007 and the Net enrolment rate(%) of Niger in 2008?
Your answer should be very brief. 49.21. What is the difference between the Net enrolment rate(%) in Mauritius in 2007 and the Net enrolment rate(%) in Netherlands in 2008?
Keep it short and to the point. -2.54. What is the difference between the Net enrolment rate(%) in Mauritius in 2007 and the Net enrolment rate(%) in Niger in 2008?
Keep it short and to the point. 48.03. What is the difference between the Net enrolment rate(%) of Netherlands in 2007 and the Net enrolment rate(%) of Niger in 2008?
Give a very brief answer. 50.48. What is the average Net enrolment rate(%) of Cuba per year?
Keep it short and to the point. 95.67. What is the average Net enrolment rate(%) in Mauritius per year?
Your answer should be compact. 95.41. What is the average Net enrolment rate(%) in Netherlands per year?
Provide a short and direct response. 98.7. What is the average Net enrolment rate(%) of Niger per year?
Offer a terse response. 40.97. In the year 2001, what is the difference between the Net enrolment rate(%) in Cuba and Net enrolment rate(%) in Mauritius?
Ensure brevity in your answer.  3. In the year 2001, what is the difference between the Net enrolment rate(%) in Cuba and Net enrolment rate(%) in Netherlands?
Your answer should be very brief. -3.47. In the year 2001, what is the difference between the Net enrolment rate(%) in Cuba and Net enrolment rate(%) in Niger?
Provide a succinct answer. 64.29. In the year 2001, what is the difference between the Net enrolment rate(%) in Mauritius and Net enrolment rate(%) in Netherlands?
Give a very brief answer. -6.47. In the year 2001, what is the difference between the Net enrolment rate(%) of Mauritius and Net enrolment rate(%) of Niger?
Provide a short and direct response. 61.29. In the year 2001, what is the difference between the Net enrolment rate(%) in Netherlands and Net enrolment rate(%) in Niger?
Provide a short and direct response. 67.75. In the year 2002, what is the difference between the Net enrolment rate(%) in Cuba and Net enrolment rate(%) in Mauritius?
Your answer should be very brief. 0.85. In the year 2002, what is the difference between the Net enrolment rate(%) in Cuba and Net enrolment rate(%) in Netherlands?
Provide a short and direct response. -3.97. In the year 2002, what is the difference between the Net enrolment rate(%) in Cuba and Net enrolment rate(%) in Niger?
Give a very brief answer. 60.2. In the year 2002, what is the difference between the Net enrolment rate(%) in Mauritius and Net enrolment rate(%) in Netherlands?
Ensure brevity in your answer.  -4.81. In the year 2002, what is the difference between the Net enrolment rate(%) in Mauritius and Net enrolment rate(%) in Niger?
Provide a short and direct response. 59.36. In the year 2002, what is the difference between the Net enrolment rate(%) of Netherlands and Net enrolment rate(%) of Niger?
Provide a short and direct response. 64.17. In the year 2003, what is the difference between the Net enrolment rate(%) of Cuba and Net enrolment rate(%) of Mauritius?
Offer a terse response. -0.41. In the year 2003, what is the difference between the Net enrolment rate(%) in Cuba and Net enrolment rate(%) in Netherlands?
Provide a succinct answer. -4.92. In the year 2003, what is the difference between the Net enrolment rate(%) in Cuba and Net enrolment rate(%) in Niger?
Give a very brief answer. 54.56. In the year 2003, what is the difference between the Net enrolment rate(%) in Mauritius and Net enrolment rate(%) in Netherlands?
Make the answer very short. -4.51. In the year 2003, what is the difference between the Net enrolment rate(%) of Mauritius and Net enrolment rate(%) of Niger?
Provide a succinct answer. 54.97. In the year 2003, what is the difference between the Net enrolment rate(%) of Netherlands and Net enrolment rate(%) of Niger?
Your answer should be very brief. 59.48. In the year 2004, what is the difference between the Net enrolment rate(%) of Cuba and Net enrolment rate(%) of Mauritius?
Offer a terse response. -1.65. In the year 2004, what is the difference between the Net enrolment rate(%) in Cuba and Net enrolment rate(%) in Netherlands?
Your response must be concise. -3.75. In the year 2004, what is the difference between the Net enrolment rate(%) in Cuba and Net enrolment rate(%) in Niger?
Give a very brief answer. 51.54. In the year 2004, what is the difference between the Net enrolment rate(%) in Mauritius and Net enrolment rate(%) in Netherlands?
Make the answer very short. -2.1. In the year 2004, what is the difference between the Net enrolment rate(%) in Mauritius and Net enrolment rate(%) in Niger?
Ensure brevity in your answer.  53.19. In the year 2004, what is the difference between the Net enrolment rate(%) in Netherlands and Net enrolment rate(%) in Niger?
Offer a very short reply. 55.29. In the year 2005, what is the difference between the Net enrolment rate(%) of Cuba and Net enrolment rate(%) of Mauritius?
Make the answer very short. -1.83. In the year 2005, what is the difference between the Net enrolment rate(%) of Cuba and Net enrolment rate(%) of Netherlands?
Make the answer very short. -3.27. In the year 2005, what is the difference between the Net enrolment rate(%) of Cuba and Net enrolment rate(%) of Niger?
Provide a short and direct response. 51.76. In the year 2005, what is the difference between the Net enrolment rate(%) of Mauritius and Net enrolment rate(%) of Netherlands?
Your answer should be compact. -1.44. In the year 2005, what is the difference between the Net enrolment rate(%) in Mauritius and Net enrolment rate(%) in Niger?
Offer a terse response. 53.59. In the year 2005, what is the difference between the Net enrolment rate(%) in Netherlands and Net enrolment rate(%) in Niger?
Make the answer very short. 55.03. In the year 2006, what is the difference between the Net enrolment rate(%) in Cuba and Net enrolment rate(%) in Mauritius?
Keep it short and to the point. -0.65. In the year 2006, what is the difference between the Net enrolment rate(%) of Cuba and Net enrolment rate(%) of Netherlands?
Provide a succinct answer. -2.83. In the year 2006, what is the difference between the Net enrolment rate(%) of Cuba and Net enrolment rate(%) of Niger?
Make the answer very short. 52.16. In the year 2006, what is the difference between the Net enrolment rate(%) of Mauritius and Net enrolment rate(%) of Netherlands?
Offer a very short reply. -2.18. In the year 2006, what is the difference between the Net enrolment rate(%) in Mauritius and Net enrolment rate(%) in Niger?
Provide a succinct answer. 52.81. In the year 2006, what is the difference between the Net enrolment rate(%) of Netherlands and Net enrolment rate(%) of Niger?
Offer a terse response. 54.99. In the year 2007, what is the difference between the Net enrolment rate(%) of Cuba and Net enrolment rate(%) of Mauritius?
Give a very brief answer. 1.18. In the year 2007, what is the difference between the Net enrolment rate(%) in Cuba and Net enrolment rate(%) in Netherlands?
Provide a succinct answer. -1.28. In the year 2007, what is the difference between the Net enrolment rate(%) in Cuba and Net enrolment rate(%) in Niger?
Make the answer very short. 53.31. In the year 2007, what is the difference between the Net enrolment rate(%) of Mauritius and Net enrolment rate(%) of Netherlands?
Your answer should be very brief. -2.46. In the year 2007, what is the difference between the Net enrolment rate(%) of Mauritius and Net enrolment rate(%) of Niger?
Make the answer very short. 52.12. In the year 2007, what is the difference between the Net enrolment rate(%) in Netherlands and Net enrolment rate(%) in Niger?
Offer a very short reply. 54.58. In the year 2008, what is the difference between the Net enrolment rate(%) of Cuba and Net enrolment rate(%) of Mauritius?
Keep it short and to the point. 1.6. In the year 2008, what is the difference between the Net enrolment rate(%) in Cuba and Net enrolment rate(%) in Netherlands?
Provide a succinct answer. -0.77. In the year 2008, what is the difference between the Net enrolment rate(%) in Cuba and Net enrolment rate(%) in Niger?
Make the answer very short. 49.79. In the year 2008, what is the difference between the Net enrolment rate(%) in Mauritius and Net enrolment rate(%) in Netherlands?
Your answer should be very brief. -2.37. In the year 2008, what is the difference between the Net enrolment rate(%) in Mauritius and Net enrolment rate(%) in Niger?
Provide a succinct answer. 48.19. In the year 2008, what is the difference between the Net enrolment rate(%) in Netherlands and Net enrolment rate(%) in Niger?
Keep it short and to the point. 50.56. What is the ratio of the Net enrolment rate(%) in Cuba in 2001 to that in 2002?
Your answer should be compact. 1.01. What is the ratio of the Net enrolment rate(%) of Mauritius in 2001 to that in 2002?
Make the answer very short. 0.98. What is the ratio of the Net enrolment rate(%) of Netherlands in 2001 to that in 2002?
Your answer should be compact. 1. What is the ratio of the Net enrolment rate(%) in Niger in 2001 to that in 2002?
Ensure brevity in your answer.  0.9. What is the ratio of the Net enrolment rate(%) of Netherlands in 2001 to that in 2003?
Your answer should be compact. 1.01. What is the ratio of the Net enrolment rate(%) of Niger in 2001 to that in 2003?
Make the answer very short. 0.81. What is the ratio of the Net enrolment rate(%) of Cuba in 2001 to that in 2004?
Make the answer very short. 1.02. What is the ratio of the Net enrolment rate(%) of Mauritius in 2001 to that in 2004?
Offer a terse response. 0.97. What is the ratio of the Net enrolment rate(%) of Netherlands in 2001 to that in 2004?
Offer a terse response. 1.02. What is the ratio of the Net enrolment rate(%) of Niger in 2001 to that in 2004?
Offer a very short reply. 0.74. What is the ratio of the Net enrolment rate(%) in Cuba in 2001 to that in 2005?
Offer a very short reply. 1.01. What is the ratio of the Net enrolment rate(%) of Mauritius in 2001 to that in 2005?
Offer a very short reply. 0.96. What is the ratio of the Net enrolment rate(%) of Netherlands in 2001 to that in 2005?
Keep it short and to the point. 1.02. What is the ratio of the Net enrolment rate(%) in Niger in 2001 to that in 2005?
Make the answer very short. 0.74. What is the ratio of the Net enrolment rate(%) of Cuba in 2001 to that in 2006?
Offer a terse response. 1. What is the ratio of the Net enrolment rate(%) of Mauritius in 2001 to that in 2006?
Your answer should be compact. 0.96. What is the ratio of the Net enrolment rate(%) of Netherlands in 2001 to that in 2006?
Offer a very short reply. 1.01. What is the ratio of the Net enrolment rate(%) in Niger in 2001 to that in 2006?
Provide a short and direct response. 0.73. What is the ratio of the Net enrolment rate(%) in Cuba in 2001 to that in 2007?
Offer a terse response. 0.98. What is the ratio of the Net enrolment rate(%) of Mauritius in 2001 to that in 2007?
Your answer should be very brief. 0.96. What is the ratio of the Net enrolment rate(%) of Netherlands in 2001 to that in 2007?
Your answer should be compact. 1. What is the ratio of the Net enrolment rate(%) of Niger in 2001 to that in 2007?
Your answer should be very brief. 0.71. What is the ratio of the Net enrolment rate(%) of Cuba in 2001 to that in 2008?
Ensure brevity in your answer.  0.97. What is the ratio of the Net enrolment rate(%) of Mauritius in 2001 to that in 2008?
Offer a terse response. 0.96. What is the ratio of the Net enrolment rate(%) in Niger in 2001 to that in 2008?
Keep it short and to the point. 0.65. What is the ratio of the Net enrolment rate(%) in Cuba in 2002 to that in 2003?
Your answer should be compact. 1.02. What is the ratio of the Net enrolment rate(%) of Mauritius in 2002 to that in 2003?
Your answer should be very brief. 1.01. What is the ratio of the Net enrolment rate(%) of Netherlands in 2002 to that in 2003?
Keep it short and to the point. 1.01. What is the ratio of the Net enrolment rate(%) of Niger in 2002 to that in 2003?
Your answer should be compact. 0.9. What is the ratio of the Net enrolment rate(%) of Cuba in 2002 to that in 2004?
Your answer should be very brief. 1.01. What is the ratio of the Net enrolment rate(%) in Mauritius in 2002 to that in 2004?
Keep it short and to the point. 0.99. What is the ratio of the Net enrolment rate(%) in Netherlands in 2002 to that in 2004?
Give a very brief answer. 1.02. What is the ratio of the Net enrolment rate(%) of Niger in 2002 to that in 2004?
Offer a terse response. 0.83. What is the ratio of the Net enrolment rate(%) of Cuba in 2002 to that in 2005?
Provide a succinct answer. 1.01. What is the ratio of the Net enrolment rate(%) in Mauritius in 2002 to that in 2005?
Your answer should be compact. 0.98. What is the ratio of the Net enrolment rate(%) of Niger in 2002 to that in 2005?
Give a very brief answer. 0.82. What is the ratio of the Net enrolment rate(%) of Mauritius in 2002 to that in 2006?
Make the answer very short. 0.98. What is the ratio of the Net enrolment rate(%) in Netherlands in 2002 to that in 2006?
Provide a succinct answer. 1.01. What is the ratio of the Net enrolment rate(%) in Niger in 2002 to that in 2006?
Your answer should be very brief. 0.81. What is the ratio of the Net enrolment rate(%) in Cuba in 2002 to that in 2007?
Offer a very short reply. 0.97. What is the ratio of the Net enrolment rate(%) of Mauritius in 2002 to that in 2007?
Provide a succinct answer. 0.98. What is the ratio of the Net enrolment rate(%) in Niger in 2002 to that in 2007?
Make the answer very short. 0.78. What is the ratio of the Net enrolment rate(%) in Cuba in 2002 to that in 2008?
Provide a succinct answer. 0.97. What is the ratio of the Net enrolment rate(%) of Mauritius in 2002 to that in 2008?
Offer a very short reply. 0.97. What is the ratio of the Net enrolment rate(%) in Netherlands in 2002 to that in 2008?
Offer a very short reply. 1. What is the ratio of the Net enrolment rate(%) of Niger in 2002 to that in 2008?
Provide a succinct answer. 0.72. What is the ratio of the Net enrolment rate(%) of Mauritius in 2003 to that in 2004?
Make the answer very short. 0.98. What is the ratio of the Net enrolment rate(%) in Netherlands in 2003 to that in 2004?
Provide a short and direct response. 1.01. What is the ratio of the Net enrolment rate(%) in Niger in 2003 to that in 2004?
Make the answer very short. 0.92. What is the ratio of the Net enrolment rate(%) in Cuba in 2003 to that in 2005?
Provide a short and direct response. 0.99. What is the ratio of the Net enrolment rate(%) in Mauritius in 2003 to that in 2005?
Your answer should be very brief. 0.97. What is the ratio of the Net enrolment rate(%) of Niger in 2003 to that in 2005?
Ensure brevity in your answer.  0.91. What is the ratio of the Net enrolment rate(%) in Cuba in 2003 to that in 2006?
Offer a very short reply. 0.98. What is the ratio of the Net enrolment rate(%) in Mauritius in 2003 to that in 2006?
Keep it short and to the point. 0.98. What is the ratio of the Net enrolment rate(%) in Netherlands in 2003 to that in 2006?
Make the answer very short. 1. What is the ratio of the Net enrolment rate(%) of Niger in 2003 to that in 2006?
Provide a succinct answer. 0.9. What is the ratio of the Net enrolment rate(%) in Cuba in 2003 to that in 2007?
Offer a terse response. 0.95. What is the ratio of the Net enrolment rate(%) of Mauritius in 2003 to that in 2007?
Ensure brevity in your answer.  0.97. What is the ratio of the Net enrolment rate(%) of Netherlands in 2003 to that in 2007?
Ensure brevity in your answer.  0.99. What is the ratio of the Net enrolment rate(%) of Niger in 2003 to that in 2007?
Your answer should be very brief. 0.87. What is the ratio of the Net enrolment rate(%) of Cuba in 2003 to that in 2008?
Your answer should be very brief. 0.95. What is the ratio of the Net enrolment rate(%) of Mauritius in 2003 to that in 2008?
Your response must be concise. 0.97. What is the ratio of the Net enrolment rate(%) of Netherlands in 2003 to that in 2008?
Make the answer very short. 0.99. What is the ratio of the Net enrolment rate(%) in Niger in 2003 to that in 2008?
Keep it short and to the point. 0.8. What is the ratio of the Net enrolment rate(%) of Mauritius in 2004 to that in 2005?
Your response must be concise. 0.99. What is the ratio of the Net enrolment rate(%) in Niger in 2004 to that in 2005?
Your answer should be very brief. 0.99. What is the ratio of the Net enrolment rate(%) in Cuba in 2004 to that in 2006?
Provide a succinct answer. 0.98. What is the ratio of the Net enrolment rate(%) in Mauritius in 2004 to that in 2006?
Provide a short and direct response. 0.99. What is the ratio of the Net enrolment rate(%) in Netherlands in 2004 to that in 2006?
Keep it short and to the point. 0.99. What is the ratio of the Net enrolment rate(%) of Niger in 2004 to that in 2006?
Provide a succinct answer. 0.98. What is the ratio of the Net enrolment rate(%) in Cuba in 2004 to that in 2007?
Offer a very short reply. 0.96. What is the ratio of the Net enrolment rate(%) of Mauritius in 2004 to that in 2007?
Keep it short and to the point. 0.99. What is the ratio of the Net enrolment rate(%) in Netherlands in 2004 to that in 2007?
Your answer should be very brief. 0.98. What is the ratio of the Net enrolment rate(%) of Niger in 2004 to that in 2007?
Your answer should be very brief. 0.95. What is the ratio of the Net enrolment rate(%) of Cuba in 2004 to that in 2008?
Your response must be concise. 0.95. What is the ratio of the Net enrolment rate(%) of Mauritius in 2004 to that in 2008?
Your response must be concise. 0.99. What is the ratio of the Net enrolment rate(%) of Netherlands in 2004 to that in 2008?
Offer a very short reply. 0.98. What is the ratio of the Net enrolment rate(%) of Niger in 2004 to that in 2008?
Offer a very short reply. 0.87. What is the ratio of the Net enrolment rate(%) of Netherlands in 2005 to that in 2006?
Ensure brevity in your answer.  0.99. What is the ratio of the Net enrolment rate(%) in Niger in 2005 to that in 2006?
Your answer should be very brief. 0.98. What is the ratio of the Net enrolment rate(%) in Cuba in 2005 to that in 2007?
Provide a short and direct response. 0.96. What is the ratio of the Net enrolment rate(%) of Mauritius in 2005 to that in 2007?
Your response must be concise. 0.99. What is the ratio of the Net enrolment rate(%) of Netherlands in 2005 to that in 2007?
Make the answer very short. 0.98. What is the ratio of the Net enrolment rate(%) in Niger in 2005 to that in 2007?
Keep it short and to the point. 0.96. What is the ratio of the Net enrolment rate(%) in Cuba in 2005 to that in 2008?
Keep it short and to the point. 0.96. What is the ratio of the Net enrolment rate(%) of Netherlands in 2005 to that in 2008?
Your answer should be very brief. 0.98. What is the ratio of the Net enrolment rate(%) in Niger in 2005 to that in 2008?
Your answer should be very brief. 0.88. What is the ratio of the Net enrolment rate(%) in Cuba in 2006 to that in 2007?
Give a very brief answer. 0.98. What is the ratio of the Net enrolment rate(%) in Mauritius in 2006 to that in 2007?
Your answer should be compact. 0.99. What is the ratio of the Net enrolment rate(%) in Netherlands in 2006 to that in 2007?
Provide a succinct answer. 0.99. What is the ratio of the Net enrolment rate(%) of Niger in 2006 to that in 2007?
Provide a short and direct response. 0.97. What is the ratio of the Net enrolment rate(%) of Cuba in 2006 to that in 2008?
Provide a succinct answer. 0.97. What is the ratio of the Net enrolment rate(%) in Niger in 2006 to that in 2008?
Ensure brevity in your answer.  0.89. What is the ratio of the Net enrolment rate(%) of Cuba in 2007 to that in 2008?
Your response must be concise. 0.99. What is the ratio of the Net enrolment rate(%) in Netherlands in 2007 to that in 2008?
Provide a short and direct response. 1. What is the ratio of the Net enrolment rate(%) in Niger in 2007 to that in 2008?
Make the answer very short. 0.92. What is the difference between the highest and the second highest Net enrolment rate(%) of Cuba?
Keep it short and to the point. 0.58. What is the difference between the highest and the second highest Net enrolment rate(%) in Mauritius?
Give a very brief answer. 0.16. What is the difference between the highest and the second highest Net enrolment rate(%) of Netherlands?
Ensure brevity in your answer.  0.08. What is the difference between the highest and the second highest Net enrolment rate(%) in Niger?
Offer a very short reply. 4.1. What is the difference between the highest and the lowest Net enrolment rate(%) in Cuba?
Your response must be concise. 5.12. What is the difference between the highest and the lowest Net enrolment rate(%) of Mauritius?
Ensure brevity in your answer.  4.19. What is the difference between the highest and the lowest Net enrolment rate(%) of Netherlands?
Keep it short and to the point. 1.61. What is the difference between the highest and the lowest Net enrolment rate(%) in Niger?
Keep it short and to the point. 17.29. 